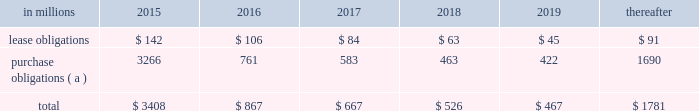At december 31 , 2014 , total future minimum commitments under existing non-cancelable operating leases and purchase obligations were as follows: .
( a ) includes $ 2.3 billion relating to fiber supply agreements entered into at the time of the company 2019s 2006 transformation plan forestland sales and in conjunction with the 2008 acquisition of weyerhaeuser company 2019s containerboard , packaging and recycling business .
Rent expense was $ 154 million , $ 168 million and $ 185 million for 2014 , 2013 and 2012 , respectively .
Guarantees in connection with sales of businesses , property , equipment , forestlands and other assets , international paper commonly makes representations and warranties relating to such businesses or assets , and may agree to indemnify buyers with respect to tax and environmental liabilities , breaches of representations and warranties , and other matters .
Where liabilities for such matters are determined to be probable and subject to reasonable estimation , accrued liabilities are recorded at the time of sale as a cost of the transaction .
Environmental proceedings cercla and state actions international paper has been named as a potentially responsible party in environmental remediation actions under various federal and state laws , including the comprehensive environmental response , compensation and liability act ( cercla ) .
Many of these proceedings involve the cleanup of hazardous substances at large commercial landfills that received waste from many different sources .
While joint and several liability is authorized under cercla and equivalent state laws , as a practical matter , liability for cercla cleanups is typically allocated among the many potential responsible parties .
Remedial costs are recorded in the consolidated financial statements when they become probable and reasonably estimable .
International paper has estimated the probable liability associated with these matters to be approximately $ 95 million in the aggregate as of december 31 , 2014 .
Cass lake : one of the matters referenced above is a closed wood treating facility located in cass lake , minnesota .
During 2009 , in connection with an environmental site remediation action under cercla , international paper submitted to the epa a remediation feasibility study .
In june 2011 , the epa selected and published a proposed soil remedy at the site with an estimated cost of $ 46 million .
The overall remediation reserve for the site is currently $ 50 million to address the selection of an alternative for the soil remediation component of the overall site remedy .
In october 2011 , the epa released a public statement indicating that the final soil remedy decision would be delayed .
In the unlikely event that the epa changes its proposed soil remedy and approves instead a more expensive clean- up alternative , the remediation costs could be material , and significantly higher than amounts currently recorded .
In october 2012 , the natural resource trustees for this site provided notice to international paper and other potentially responsible parties of their intent to perform a natural resource damage assessment .
It is premature to predict the outcome of the assessment or to estimate a loss or range of loss , if any , which may be incurred .
Other remediation costs in addition to the above matters , other remediation costs typically associated with the cleanup of hazardous substances at the company 2019s current , closed or formerly-owned facilities , and recorded as liabilities in the balance sheet , totaled approximately $ 41 million as of december 31 , 2014 .
Other than as described above , completion of required remedial actions is not expected to have a material effect on our consolidated financial statements .
Legal proceedings environmental kalamazoo river : the company is a potentially responsible party with respect to the allied paper , inc./ portage creek/kalamazoo river superfund site ( kalamazoo river superfund site ) in michigan .
The epa asserts that the site is contaminated primarily by pcbs as a result of discharges from various paper mills located along the kalamazoo river , including a paper mill formerly owned by st .
Regis paper company ( st .
Regis ) .
The company is a successor in interest to st .
Regis .
Although the company has not received any orders from the epa , in december 2014 , the epa sent the company a letter demanding payment of $ 19 million to reimburse the epa for costs associated with a time critical removal action of pcb contaminated sediments from a portion of the site .
The company 2019s cercla liability has not been finally determined with respect to this or any other portion of the site and we have declined to reimburse the epa at this time .
As noted below , the company is involved in allocation/ apportionment litigation with regard to the site .
Accordingly , it is premature to estimate a loss or range of loss with respect to this site .
The company was named as a defendant by georgia- pacific consumer products lp , fort james corporation and georgia pacific llc in a contribution and cost recovery action for alleged pollution at the site .
The suit .
At december 31 , 2014 what was the percent of the total future minimum commitments under existing non-cancelable purchase obligations in 2016? 
Computations: (761 / 867)
Answer: 0.87774. 